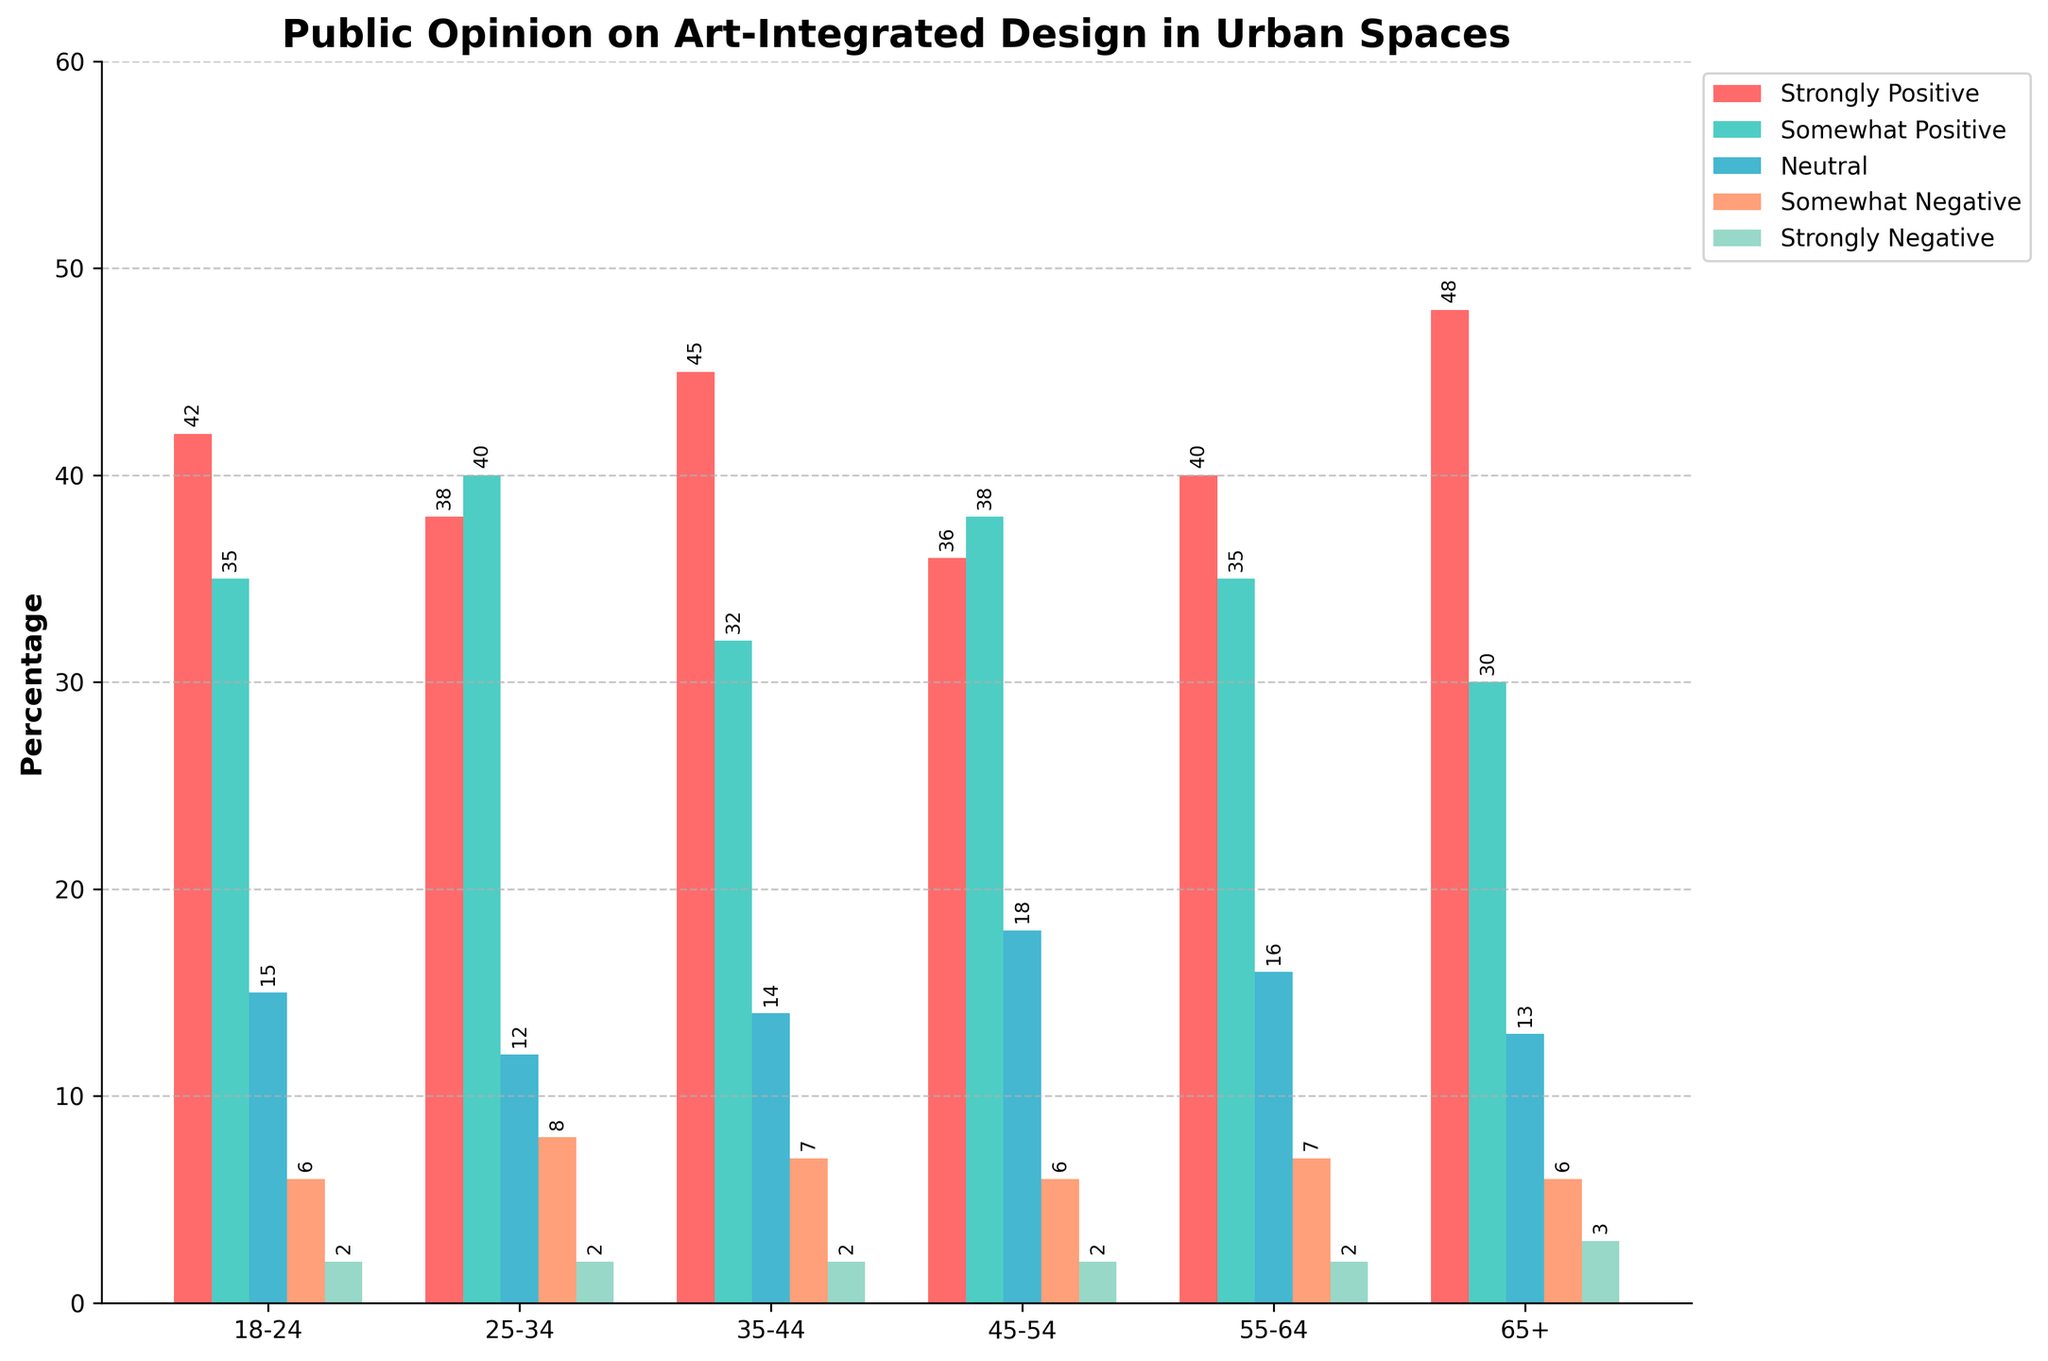What age group shows the highest percentage of Strongly Positive opinions? The age group with the highest percentage of Strongly Positive opinions can be identified by comparing the heights of the corresponding bars. The 65+ group has the tallest bar in the Strongly Positive category.
Answer: 65+ Which age group has the lowest percentage for the Neutral category? To identify the age group with the lowest percentage in the Neutral category, compare the heights of the bars. The 18-24 age group has the shortest bar in the Neutral category.
Answer: 18-24 What is the sum of Strongly Negative and Somewhat Negative opinions in the 25-34 age group? Add the percentages for Strongly Negative (2%) and Somewhat Negative (8%) within the 25-34 age group. The sum is 2 + 8 = 10%.
Answer: 10% Which two age groups have the same percentage for the Strongly Positive category? Compare the heights of the Strongly Positive bars across age groups to find those that are equal. The 25-34 and 45-54 age groups both have 38% for Strongly Positive.
Answer: 25-34 and 45-54 What is the average percentage of Somewhat Positive opinions across all age groups? Sum the percentages of Somewhat Positive opinions for all age groups and divide by the number of age groups. (35 + 40 + 32 + 38 + 35 + 30) / 6 = 35.
Answer: 35 How does the percentage of Strongly Negative opinions in the 65+ age group compare to that in the 45-54 age group? Compare the heights of the Strongly Negative bars for the 65+ and 45-54 age groups. Both have Strongly Negative opinions at 2%, indicating they are equal.
Answer: Equal Which color represents the Neutral category, and what percentage does it represent for the 55-64 age group? Find the color associated with the Neutral column and check the height/bar value for the 55-64 age group in that color. The Neutral category is represented by blue, and for the 55-64 age group, the percentage is 16%.
Answer: Blue, 16% What is the difference between the percentages of Strongly Positive opinions for 35-44 and 18-24 age groups? Subtract the percentage of Strongly Positive opinions in the 18-24 age group (42%) from the percentage in the 35-44 age group (45%). The difference is 45 - 42 = 3%.
Answer: 3% Which age group has the most balanced (lowest variation) opinion distribution among all five categories? Compare the range (difference between the maximum and minimum values) of percentages across all categories for each age group. The 25-34 age group has the smallest range from 2% to 40%, showing the most balanced distribution.
Answer: 25-34 